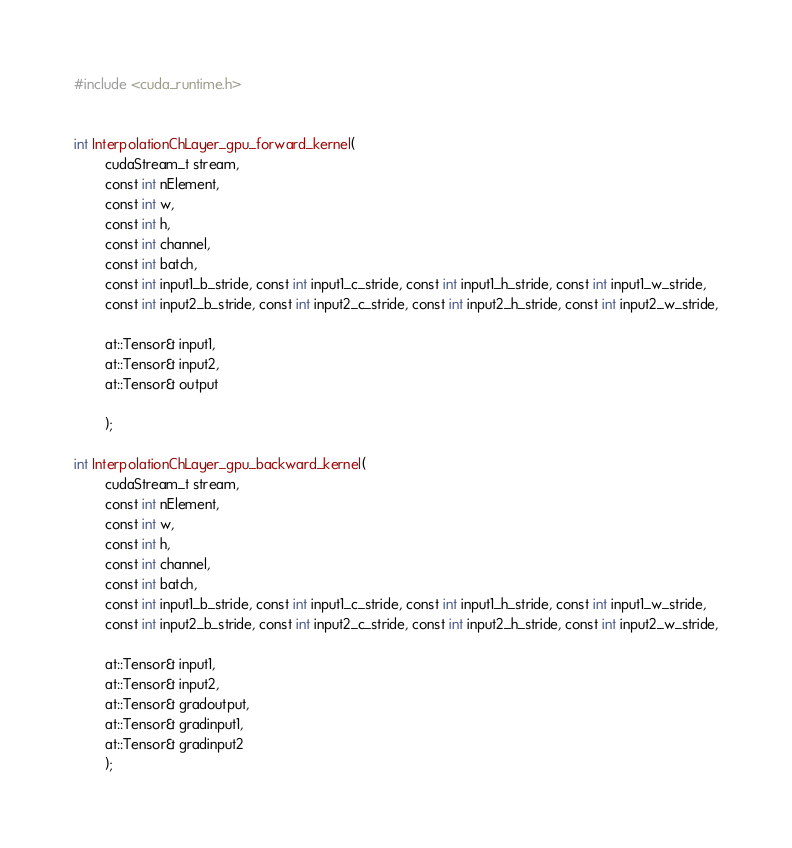Convert code to text. <code><loc_0><loc_0><loc_500><loc_500><_Cuda_>#include <cuda_runtime.h>


int InterpolationChLayer_gpu_forward_kernel(
		cudaStream_t stream,
		const int nElement,
		const int w,
		const int h,
		const int channel,
		const int batch,
		const int input1_b_stride, const int input1_c_stride, const int input1_h_stride, const int input1_w_stride,
		const int input2_b_stride, const int input2_c_stride, const int input2_h_stride, const int input2_w_stride,

		at::Tensor& input1,
		at::Tensor& input2,
		at::Tensor& output

		);
 
int InterpolationChLayer_gpu_backward_kernel(
		cudaStream_t stream,
		const int nElement,
		const int w,
		const int h,
		const int channel,
		const int batch,
		const int input1_b_stride, const int input1_c_stride, const int input1_h_stride, const int input1_w_stride,
		const int input2_b_stride, const int input2_c_stride, const int input2_h_stride, const int input2_w_stride,

		at::Tensor& input1,
		at::Tensor& input2,
		at::Tensor& gradoutput,
		at::Tensor& gradinput1,
		at::Tensor& gradinput2
		);
</code> 